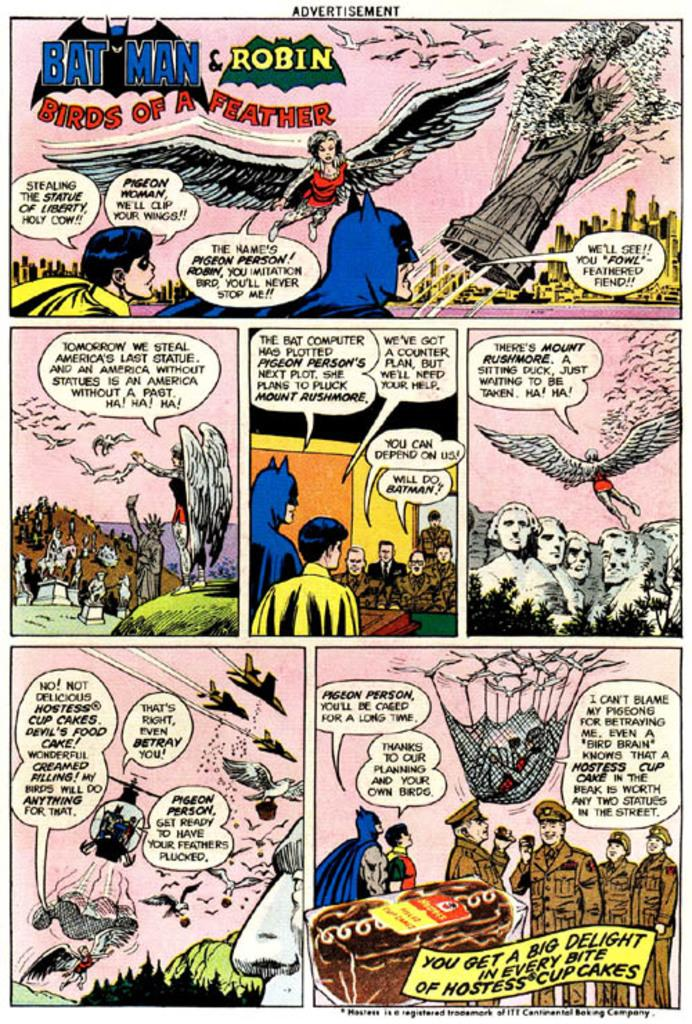What is present in the image? There is a poster in the image. Can you describe the poster? The poster appears to be a collage. Can you see the friend's face in the image? There is no friend or face present in the image; it only features a poster that appears to be a collage. 